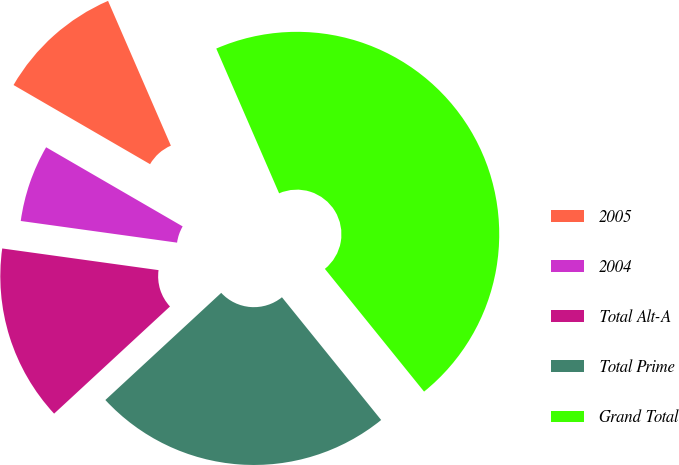Convert chart. <chart><loc_0><loc_0><loc_500><loc_500><pie_chart><fcel>2005<fcel>2004<fcel>Total Alt-A<fcel>Total Prime<fcel>Grand Total<nl><fcel>10.12%<fcel>6.17%<fcel>14.07%<fcel>23.94%<fcel>45.7%<nl></chart> 